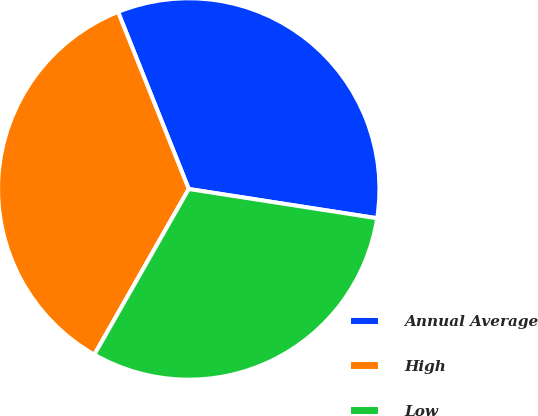Convert chart. <chart><loc_0><loc_0><loc_500><loc_500><pie_chart><fcel>Annual Average<fcel>High<fcel>Low<nl><fcel>33.5%<fcel>35.71%<fcel>30.79%<nl></chart> 